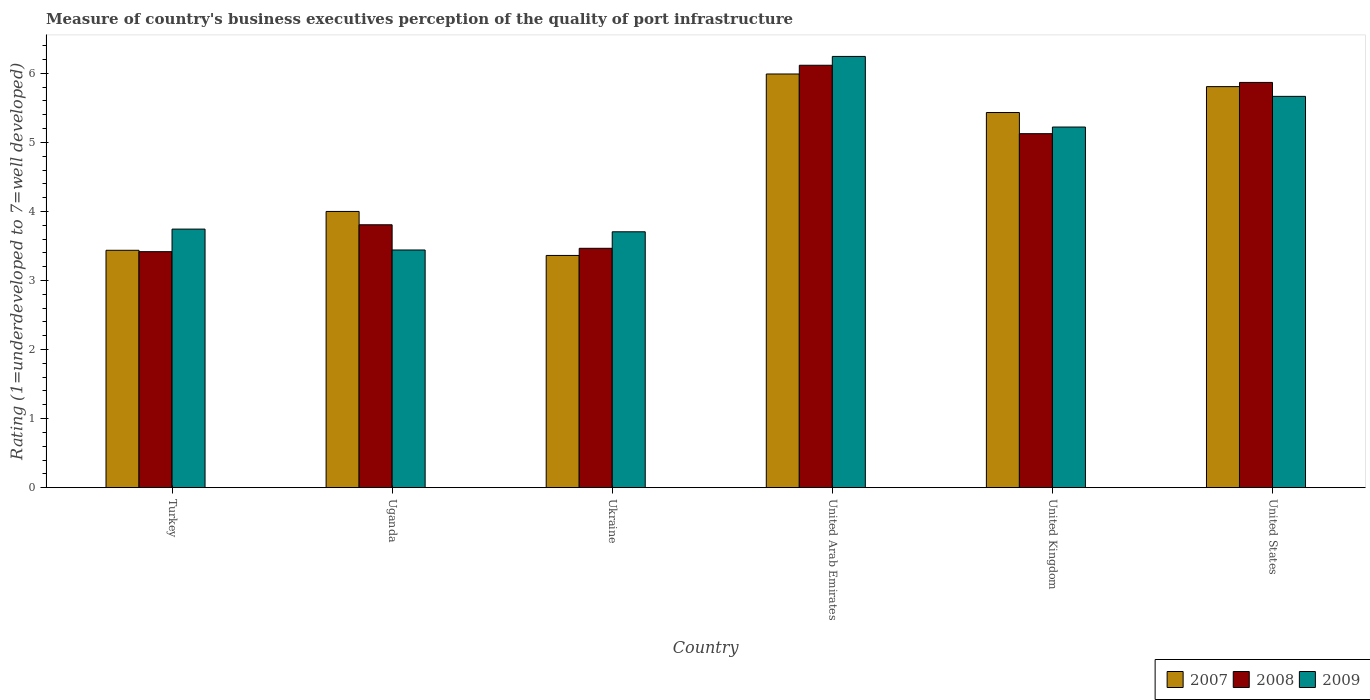How many groups of bars are there?
Offer a terse response. 6. How many bars are there on the 5th tick from the right?
Ensure brevity in your answer.  3. What is the label of the 4th group of bars from the left?
Provide a short and direct response. United Arab Emirates. In how many cases, is the number of bars for a given country not equal to the number of legend labels?
Ensure brevity in your answer.  0. What is the ratings of the quality of port infrastructure in 2009 in United Kingdom?
Your response must be concise. 5.22. Across all countries, what is the maximum ratings of the quality of port infrastructure in 2007?
Your answer should be compact. 5.99. Across all countries, what is the minimum ratings of the quality of port infrastructure in 2007?
Offer a very short reply. 3.36. In which country was the ratings of the quality of port infrastructure in 2007 maximum?
Your response must be concise. United Arab Emirates. In which country was the ratings of the quality of port infrastructure in 2009 minimum?
Your response must be concise. Uganda. What is the total ratings of the quality of port infrastructure in 2007 in the graph?
Offer a terse response. 28.03. What is the difference between the ratings of the quality of port infrastructure in 2007 in Uganda and that in United Kingdom?
Keep it short and to the point. -1.43. What is the difference between the ratings of the quality of port infrastructure in 2007 in United Arab Emirates and the ratings of the quality of port infrastructure in 2008 in United States?
Make the answer very short. 0.12. What is the average ratings of the quality of port infrastructure in 2009 per country?
Ensure brevity in your answer.  4.67. What is the difference between the ratings of the quality of port infrastructure of/in 2008 and ratings of the quality of port infrastructure of/in 2009 in Uganda?
Make the answer very short. 0.37. In how many countries, is the ratings of the quality of port infrastructure in 2009 greater than 5.8?
Offer a very short reply. 1. What is the ratio of the ratings of the quality of port infrastructure in 2009 in Turkey to that in Uganda?
Give a very brief answer. 1.09. Is the difference between the ratings of the quality of port infrastructure in 2008 in Turkey and Uganda greater than the difference between the ratings of the quality of port infrastructure in 2009 in Turkey and Uganda?
Make the answer very short. No. What is the difference between the highest and the second highest ratings of the quality of port infrastructure in 2008?
Your answer should be compact. -0.74. What is the difference between the highest and the lowest ratings of the quality of port infrastructure in 2008?
Make the answer very short. 2.7. In how many countries, is the ratings of the quality of port infrastructure in 2009 greater than the average ratings of the quality of port infrastructure in 2009 taken over all countries?
Keep it short and to the point. 3. Is the sum of the ratings of the quality of port infrastructure in 2009 in United Kingdom and United States greater than the maximum ratings of the quality of port infrastructure in 2007 across all countries?
Give a very brief answer. Yes. What does the 3rd bar from the left in United Kingdom represents?
Make the answer very short. 2009. What does the 3rd bar from the right in United Kingdom represents?
Your response must be concise. 2007. Are all the bars in the graph horizontal?
Your answer should be very brief. No. Does the graph contain grids?
Keep it short and to the point. No. How many legend labels are there?
Give a very brief answer. 3. How are the legend labels stacked?
Give a very brief answer. Horizontal. What is the title of the graph?
Provide a succinct answer. Measure of country's business executives perception of the quality of port infrastructure. Does "1994" appear as one of the legend labels in the graph?
Give a very brief answer. No. What is the label or title of the X-axis?
Make the answer very short. Country. What is the label or title of the Y-axis?
Ensure brevity in your answer.  Rating (1=underdeveloped to 7=well developed). What is the Rating (1=underdeveloped to 7=well developed) in 2007 in Turkey?
Provide a short and direct response. 3.44. What is the Rating (1=underdeveloped to 7=well developed) of 2008 in Turkey?
Provide a short and direct response. 3.42. What is the Rating (1=underdeveloped to 7=well developed) in 2009 in Turkey?
Provide a succinct answer. 3.74. What is the Rating (1=underdeveloped to 7=well developed) in 2007 in Uganda?
Keep it short and to the point. 4. What is the Rating (1=underdeveloped to 7=well developed) in 2008 in Uganda?
Offer a terse response. 3.81. What is the Rating (1=underdeveloped to 7=well developed) of 2009 in Uganda?
Give a very brief answer. 3.44. What is the Rating (1=underdeveloped to 7=well developed) in 2007 in Ukraine?
Provide a short and direct response. 3.36. What is the Rating (1=underdeveloped to 7=well developed) of 2008 in Ukraine?
Give a very brief answer. 3.47. What is the Rating (1=underdeveloped to 7=well developed) of 2009 in Ukraine?
Your response must be concise. 3.71. What is the Rating (1=underdeveloped to 7=well developed) of 2007 in United Arab Emirates?
Offer a terse response. 5.99. What is the Rating (1=underdeveloped to 7=well developed) in 2008 in United Arab Emirates?
Keep it short and to the point. 6.12. What is the Rating (1=underdeveloped to 7=well developed) in 2009 in United Arab Emirates?
Give a very brief answer. 6.24. What is the Rating (1=underdeveloped to 7=well developed) of 2007 in United Kingdom?
Ensure brevity in your answer.  5.43. What is the Rating (1=underdeveloped to 7=well developed) in 2008 in United Kingdom?
Ensure brevity in your answer.  5.13. What is the Rating (1=underdeveloped to 7=well developed) of 2009 in United Kingdom?
Keep it short and to the point. 5.22. What is the Rating (1=underdeveloped to 7=well developed) of 2007 in United States?
Keep it short and to the point. 5.81. What is the Rating (1=underdeveloped to 7=well developed) of 2008 in United States?
Provide a short and direct response. 5.87. What is the Rating (1=underdeveloped to 7=well developed) of 2009 in United States?
Your response must be concise. 5.67. Across all countries, what is the maximum Rating (1=underdeveloped to 7=well developed) of 2007?
Make the answer very short. 5.99. Across all countries, what is the maximum Rating (1=underdeveloped to 7=well developed) of 2008?
Keep it short and to the point. 6.12. Across all countries, what is the maximum Rating (1=underdeveloped to 7=well developed) in 2009?
Offer a very short reply. 6.24. Across all countries, what is the minimum Rating (1=underdeveloped to 7=well developed) in 2007?
Offer a very short reply. 3.36. Across all countries, what is the minimum Rating (1=underdeveloped to 7=well developed) in 2008?
Offer a terse response. 3.42. Across all countries, what is the minimum Rating (1=underdeveloped to 7=well developed) in 2009?
Provide a succinct answer. 3.44. What is the total Rating (1=underdeveloped to 7=well developed) of 2007 in the graph?
Provide a succinct answer. 28.03. What is the total Rating (1=underdeveloped to 7=well developed) of 2008 in the graph?
Your answer should be very brief. 27.8. What is the total Rating (1=underdeveloped to 7=well developed) in 2009 in the graph?
Give a very brief answer. 28.03. What is the difference between the Rating (1=underdeveloped to 7=well developed) in 2007 in Turkey and that in Uganda?
Your answer should be compact. -0.56. What is the difference between the Rating (1=underdeveloped to 7=well developed) of 2008 in Turkey and that in Uganda?
Provide a succinct answer. -0.39. What is the difference between the Rating (1=underdeveloped to 7=well developed) in 2009 in Turkey and that in Uganda?
Make the answer very short. 0.3. What is the difference between the Rating (1=underdeveloped to 7=well developed) of 2007 in Turkey and that in Ukraine?
Your response must be concise. 0.07. What is the difference between the Rating (1=underdeveloped to 7=well developed) in 2008 in Turkey and that in Ukraine?
Offer a terse response. -0.05. What is the difference between the Rating (1=underdeveloped to 7=well developed) in 2009 in Turkey and that in Ukraine?
Provide a succinct answer. 0.04. What is the difference between the Rating (1=underdeveloped to 7=well developed) of 2007 in Turkey and that in United Arab Emirates?
Provide a succinct answer. -2.55. What is the difference between the Rating (1=underdeveloped to 7=well developed) in 2008 in Turkey and that in United Arab Emirates?
Your response must be concise. -2.7. What is the difference between the Rating (1=underdeveloped to 7=well developed) in 2009 in Turkey and that in United Arab Emirates?
Make the answer very short. -2.5. What is the difference between the Rating (1=underdeveloped to 7=well developed) in 2007 in Turkey and that in United Kingdom?
Your response must be concise. -2. What is the difference between the Rating (1=underdeveloped to 7=well developed) of 2008 in Turkey and that in United Kingdom?
Offer a very short reply. -1.71. What is the difference between the Rating (1=underdeveloped to 7=well developed) of 2009 in Turkey and that in United Kingdom?
Your response must be concise. -1.48. What is the difference between the Rating (1=underdeveloped to 7=well developed) in 2007 in Turkey and that in United States?
Ensure brevity in your answer.  -2.37. What is the difference between the Rating (1=underdeveloped to 7=well developed) in 2008 in Turkey and that in United States?
Offer a terse response. -2.45. What is the difference between the Rating (1=underdeveloped to 7=well developed) of 2009 in Turkey and that in United States?
Ensure brevity in your answer.  -1.92. What is the difference between the Rating (1=underdeveloped to 7=well developed) of 2007 in Uganda and that in Ukraine?
Ensure brevity in your answer.  0.64. What is the difference between the Rating (1=underdeveloped to 7=well developed) of 2008 in Uganda and that in Ukraine?
Provide a succinct answer. 0.34. What is the difference between the Rating (1=underdeveloped to 7=well developed) of 2009 in Uganda and that in Ukraine?
Offer a terse response. -0.26. What is the difference between the Rating (1=underdeveloped to 7=well developed) in 2007 in Uganda and that in United Arab Emirates?
Your answer should be very brief. -1.99. What is the difference between the Rating (1=underdeveloped to 7=well developed) of 2008 in Uganda and that in United Arab Emirates?
Your response must be concise. -2.31. What is the difference between the Rating (1=underdeveloped to 7=well developed) of 2009 in Uganda and that in United Arab Emirates?
Your answer should be compact. -2.8. What is the difference between the Rating (1=underdeveloped to 7=well developed) of 2007 in Uganda and that in United Kingdom?
Your answer should be compact. -1.43. What is the difference between the Rating (1=underdeveloped to 7=well developed) of 2008 in Uganda and that in United Kingdom?
Offer a very short reply. -1.32. What is the difference between the Rating (1=underdeveloped to 7=well developed) in 2009 in Uganda and that in United Kingdom?
Offer a very short reply. -1.78. What is the difference between the Rating (1=underdeveloped to 7=well developed) in 2007 in Uganda and that in United States?
Make the answer very short. -1.81. What is the difference between the Rating (1=underdeveloped to 7=well developed) of 2008 in Uganda and that in United States?
Your answer should be very brief. -2.06. What is the difference between the Rating (1=underdeveloped to 7=well developed) in 2009 in Uganda and that in United States?
Your response must be concise. -2.22. What is the difference between the Rating (1=underdeveloped to 7=well developed) of 2007 in Ukraine and that in United Arab Emirates?
Your answer should be very brief. -2.63. What is the difference between the Rating (1=underdeveloped to 7=well developed) in 2008 in Ukraine and that in United Arab Emirates?
Provide a short and direct response. -2.65. What is the difference between the Rating (1=underdeveloped to 7=well developed) of 2009 in Ukraine and that in United Arab Emirates?
Give a very brief answer. -2.54. What is the difference between the Rating (1=underdeveloped to 7=well developed) in 2007 in Ukraine and that in United Kingdom?
Provide a succinct answer. -2.07. What is the difference between the Rating (1=underdeveloped to 7=well developed) of 2008 in Ukraine and that in United Kingdom?
Ensure brevity in your answer.  -1.66. What is the difference between the Rating (1=underdeveloped to 7=well developed) of 2009 in Ukraine and that in United Kingdom?
Your answer should be compact. -1.52. What is the difference between the Rating (1=underdeveloped to 7=well developed) in 2007 in Ukraine and that in United States?
Provide a short and direct response. -2.44. What is the difference between the Rating (1=underdeveloped to 7=well developed) of 2008 in Ukraine and that in United States?
Make the answer very short. -2.4. What is the difference between the Rating (1=underdeveloped to 7=well developed) in 2009 in Ukraine and that in United States?
Provide a short and direct response. -1.96. What is the difference between the Rating (1=underdeveloped to 7=well developed) of 2007 in United Arab Emirates and that in United Kingdom?
Keep it short and to the point. 0.56. What is the difference between the Rating (1=underdeveloped to 7=well developed) in 2008 in United Arab Emirates and that in United Kingdom?
Keep it short and to the point. 0.99. What is the difference between the Rating (1=underdeveloped to 7=well developed) in 2009 in United Arab Emirates and that in United Kingdom?
Provide a short and direct response. 1.02. What is the difference between the Rating (1=underdeveloped to 7=well developed) of 2007 in United Arab Emirates and that in United States?
Provide a succinct answer. 0.18. What is the difference between the Rating (1=underdeveloped to 7=well developed) in 2008 in United Arab Emirates and that in United States?
Ensure brevity in your answer.  0.25. What is the difference between the Rating (1=underdeveloped to 7=well developed) of 2009 in United Arab Emirates and that in United States?
Provide a short and direct response. 0.58. What is the difference between the Rating (1=underdeveloped to 7=well developed) of 2007 in United Kingdom and that in United States?
Keep it short and to the point. -0.38. What is the difference between the Rating (1=underdeveloped to 7=well developed) in 2008 in United Kingdom and that in United States?
Your response must be concise. -0.74. What is the difference between the Rating (1=underdeveloped to 7=well developed) in 2009 in United Kingdom and that in United States?
Give a very brief answer. -0.44. What is the difference between the Rating (1=underdeveloped to 7=well developed) of 2007 in Turkey and the Rating (1=underdeveloped to 7=well developed) of 2008 in Uganda?
Give a very brief answer. -0.37. What is the difference between the Rating (1=underdeveloped to 7=well developed) in 2007 in Turkey and the Rating (1=underdeveloped to 7=well developed) in 2009 in Uganda?
Provide a short and direct response. -0. What is the difference between the Rating (1=underdeveloped to 7=well developed) in 2008 in Turkey and the Rating (1=underdeveloped to 7=well developed) in 2009 in Uganda?
Your answer should be compact. -0.02. What is the difference between the Rating (1=underdeveloped to 7=well developed) in 2007 in Turkey and the Rating (1=underdeveloped to 7=well developed) in 2008 in Ukraine?
Ensure brevity in your answer.  -0.03. What is the difference between the Rating (1=underdeveloped to 7=well developed) of 2007 in Turkey and the Rating (1=underdeveloped to 7=well developed) of 2009 in Ukraine?
Your response must be concise. -0.27. What is the difference between the Rating (1=underdeveloped to 7=well developed) in 2008 in Turkey and the Rating (1=underdeveloped to 7=well developed) in 2009 in Ukraine?
Give a very brief answer. -0.29. What is the difference between the Rating (1=underdeveloped to 7=well developed) in 2007 in Turkey and the Rating (1=underdeveloped to 7=well developed) in 2008 in United Arab Emirates?
Offer a very short reply. -2.68. What is the difference between the Rating (1=underdeveloped to 7=well developed) in 2007 in Turkey and the Rating (1=underdeveloped to 7=well developed) in 2009 in United Arab Emirates?
Provide a succinct answer. -2.81. What is the difference between the Rating (1=underdeveloped to 7=well developed) of 2008 in Turkey and the Rating (1=underdeveloped to 7=well developed) of 2009 in United Arab Emirates?
Your answer should be compact. -2.83. What is the difference between the Rating (1=underdeveloped to 7=well developed) of 2007 in Turkey and the Rating (1=underdeveloped to 7=well developed) of 2008 in United Kingdom?
Ensure brevity in your answer.  -1.69. What is the difference between the Rating (1=underdeveloped to 7=well developed) of 2007 in Turkey and the Rating (1=underdeveloped to 7=well developed) of 2009 in United Kingdom?
Your response must be concise. -1.78. What is the difference between the Rating (1=underdeveloped to 7=well developed) of 2008 in Turkey and the Rating (1=underdeveloped to 7=well developed) of 2009 in United Kingdom?
Make the answer very short. -1.8. What is the difference between the Rating (1=underdeveloped to 7=well developed) in 2007 in Turkey and the Rating (1=underdeveloped to 7=well developed) in 2008 in United States?
Your answer should be very brief. -2.43. What is the difference between the Rating (1=underdeveloped to 7=well developed) of 2007 in Turkey and the Rating (1=underdeveloped to 7=well developed) of 2009 in United States?
Your answer should be compact. -2.23. What is the difference between the Rating (1=underdeveloped to 7=well developed) in 2008 in Turkey and the Rating (1=underdeveloped to 7=well developed) in 2009 in United States?
Your answer should be very brief. -2.25. What is the difference between the Rating (1=underdeveloped to 7=well developed) in 2007 in Uganda and the Rating (1=underdeveloped to 7=well developed) in 2008 in Ukraine?
Keep it short and to the point. 0.53. What is the difference between the Rating (1=underdeveloped to 7=well developed) of 2007 in Uganda and the Rating (1=underdeveloped to 7=well developed) of 2009 in Ukraine?
Provide a short and direct response. 0.29. What is the difference between the Rating (1=underdeveloped to 7=well developed) in 2008 in Uganda and the Rating (1=underdeveloped to 7=well developed) in 2009 in Ukraine?
Your response must be concise. 0.1. What is the difference between the Rating (1=underdeveloped to 7=well developed) in 2007 in Uganda and the Rating (1=underdeveloped to 7=well developed) in 2008 in United Arab Emirates?
Ensure brevity in your answer.  -2.12. What is the difference between the Rating (1=underdeveloped to 7=well developed) in 2007 in Uganda and the Rating (1=underdeveloped to 7=well developed) in 2009 in United Arab Emirates?
Offer a terse response. -2.25. What is the difference between the Rating (1=underdeveloped to 7=well developed) in 2008 in Uganda and the Rating (1=underdeveloped to 7=well developed) in 2009 in United Arab Emirates?
Make the answer very short. -2.44. What is the difference between the Rating (1=underdeveloped to 7=well developed) in 2007 in Uganda and the Rating (1=underdeveloped to 7=well developed) in 2008 in United Kingdom?
Your answer should be very brief. -1.13. What is the difference between the Rating (1=underdeveloped to 7=well developed) in 2007 in Uganda and the Rating (1=underdeveloped to 7=well developed) in 2009 in United Kingdom?
Give a very brief answer. -1.22. What is the difference between the Rating (1=underdeveloped to 7=well developed) in 2008 in Uganda and the Rating (1=underdeveloped to 7=well developed) in 2009 in United Kingdom?
Ensure brevity in your answer.  -1.42. What is the difference between the Rating (1=underdeveloped to 7=well developed) in 2007 in Uganda and the Rating (1=underdeveloped to 7=well developed) in 2008 in United States?
Ensure brevity in your answer.  -1.87. What is the difference between the Rating (1=underdeveloped to 7=well developed) in 2007 in Uganda and the Rating (1=underdeveloped to 7=well developed) in 2009 in United States?
Provide a short and direct response. -1.67. What is the difference between the Rating (1=underdeveloped to 7=well developed) in 2008 in Uganda and the Rating (1=underdeveloped to 7=well developed) in 2009 in United States?
Offer a terse response. -1.86. What is the difference between the Rating (1=underdeveloped to 7=well developed) in 2007 in Ukraine and the Rating (1=underdeveloped to 7=well developed) in 2008 in United Arab Emirates?
Make the answer very short. -2.75. What is the difference between the Rating (1=underdeveloped to 7=well developed) of 2007 in Ukraine and the Rating (1=underdeveloped to 7=well developed) of 2009 in United Arab Emirates?
Your response must be concise. -2.88. What is the difference between the Rating (1=underdeveloped to 7=well developed) in 2008 in Ukraine and the Rating (1=underdeveloped to 7=well developed) in 2009 in United Arab Emirates?
Keep it short and to the point. -2.78. What is the difference between the Rating (1=underdeveloped to 7=well developed) in 2007 in Ukraine and the Rating (1=underdeveloped to 7=well developed) in 2008 in United Kingdom?
Give a very brief answer. -1.76. What is the difference between the Rating (1=underdeveloped to 7=well developed) of 2007 in Ukraine and the Rating (1=underdeveloped to 7=well developed) of 2009 in United Kingdom?
Offer a very short reply. -1.86. What is the difference between the Rating (1=underdeveloped to 7=well developed) of 2008 in Ukraine and the Rating (1=underdeveloped to 7=well developed) of 2009 in United Kingdom?
Provide a short and direct response. -1.76. What is the difference between the Rating (1=underdeveloped to 7=well developed) of 2007 in Ukraine and the Rating (1=underdeveloped to 7=well developed) of 2008 in United States?
Give a very brief answer. -2.51. What is the difference between the Rating (1=underdeveloped to 7=well developed) in 2007 in Ukraine and the Rating (1=underdeveloped to 7=well developed) in 2009 in United States?
Offer a terse response. -2.3. What is the difference between the Rating (1=underdeveloped to 7=well developed) of 2008 in Ukraine and the Rating (1=underdeveloped to 7=well developed) of 2009 in United States?
Ensure brevity in your answer.  -2.2. What is the difference between the Rating (1=underdeveloped to 7=well developed) in 2007 in United Arab Emirates and the Rating (1=underdeveloped to 7=well developed) in 2008 in United Kingdom?
Provide a short and direct response. 0.86. What is the difference between the Rating (1=underdeveloped to 7=well developed) in 2007 in United Arab Emirates and the Rating (1=underdeveloped to 7=well developed) in 2009 in United Kingdom?
Your answer should be compact. 0.77. What is the difference between the Rating (1=underdeveloped to 7=well developed) of 2008 in United Arab Emirates and the Rating (1=underdeveloped to 7=well developed) of 2009 in United Kingdom?
Provide a short and direct response. 0.89. What is the difference between the Rating (1=underdeveloped to 7=well developed) in 2007 in United Arab Emirates and the Rating (1=underdeveloped to 7=well developed) in 2008 in United States?
Keep it short and to the point. 0.12. What is the difference between the Rating (1=underdeveloped to 7=well developed) in 2007 in United Arab Emirates and the Rating (1=underdeveloped to 7=well developed) in 2009 in United States?
Offer a terse response. 0.32. What is the difference between the Rating (1=underdeveloped to 7=well developed) in 2008 in United Arab Emirates and the Rating (1=underdeveloped to 7=well developed) in 2009 in United States?
Provide a short and direct response. 0.45. What is the difference between the Rating (1=underdeveloped to 7=well developed) of 2007 in United Kingdom and the Rating (1=underdeveloped to 7=well developed) of 2008 in United States?
Give a very brief answer. -0.44. What is the difference between the Rating (1=underdeveloped to 7=well developed) of 2007 in United Kingdom and the Rating (1=underdeveloped to 7=well developed) of 2009 in United States?
Offer a terse response. -0.23. What is the difference between the Rating (1=underdeveloped to 7=well developed) in 2008 in United Kingdom and the Rating (1=underdeveloped to 7=well developed) in 2009 in United States?
Keep it short and to the point. -0.54. What is the average Rating (1=underdeveloped to 7=well developed) in 2007 per country?
Offer a very short reply. 4.67. What is the average Rating (1=underdeveloped to 7=well developed) in 2008 per country?
Your response must be concise. 4.63. What is the average Rating (1=underdeveloped to 7=well developed) in 2009 per country?
Ensure brevity in your answer.  4.67. What is the difference between the Rating (1=underdeveloped to 7=well developed) in 2007 and Rating (1=underdeveloped to 7=well developed) in 2008 in Turkey?
Your answer should be very brief. 0.02. What is the difference between the Rating (1=underdeveloped to 7=well developed) in 2007 and Rating (1=underdeveloped to 7=well developed) in 2009 in Turkey?
Your answer should be very brief. -0.31. What is the difference between the Rating (1=underdeveloped to 7=well developed) in 2008 and Rating (1=underdeveloped to 7=well developed) in 2009 in Turkey?
Provide a short and direct response. -0.33. What is the difference between the Rating (1=underdeveloped to 7=well developed) of 2007 and Rating (1=underdeveloped to 7=well developed) of 2008 in Uganda?
Your answer should be very brief. 0.19. What is the difference between the Rating (1=underdeveloped to 7=well developed) of 2007 and Rating (1=underdeveloped to 7=well developed) of 2009 in Uganda?
Provide a succinct answer. 0.56. What is the difference between the Rating (1=underdeveloped to 7=well developed) of 2008 and Rating (1=underdeveloped to 7=well developed) of 2009 in Uganda?
Offer a very short reply. 0.37. What is the difference between the Rating (1=underdeveloped to 7=well developed) of 2007 and Rating (1=underdeveloped to 7=well developed) of 2008 in Ukraine?
Your answer should be compact. -0.1. What is the difference between the Rating (1=underdeveloped to 7=well developed) of 2007 and Rating (1=underdeveloped to 7=well developed) of 2009 in Ukraine?
Provide a short and direct response. -0.34. What is the difference between the Rating (1=underdeveloped to 7=well developed) of 2008 and Rating (1=underdeveloped to 7=well developed) of 2009 in Ukraine?
Keep it short and to the point. -0.24. What is the difference between the Rating (1=underdeveloped to 7=well developed) of 2007 and Rating (1=underdeveloped to 7=well developed) of 2008 in United Arab Emirates?
Offer a terse response. -0.13. What is the difference between the Rating (1=underdeveloped to 7=well developed) of 2007 and Rating (1=underdeveloped to 7=well developed) of 2009 in United Arab Emirates?
Offer a very short reply. -0.25. What is the difference between the Rating (1=underdeveloped to 7=well developed) in 2008 and Rating (1=underdeveloped to 7=well developed) in 2009 in United Arab Emirates?
Your answer should be compact. -0.13. What is the difference between the Rating (1=underdeveloped to 7=well developed) in 2007 and Rating (1=underdeveloped to 7=well developed) in 2008 in United Kingdom?
Your response must be concise. 0.31. What is the difference between the Rating (1=underdeveloped to 7=well developed) of 2007 and Rating (1=underdeveloped to 7=well developed) of 2009 in United Kingdom?
Your answer should be very brief. 0.21. What is the difference between the Rating (1=underdeveloped to 7=well developed) in 2008 and Rating (1=underdeveloped to 7=well developed) in 2009 in United Kingdom?
Offer a very short reply. -0.1. What is the difference between the Rating (1=underdeveloped to 7=well developed) of 2007 and Rating (1=underdeveloped to 7=well developed) of 2008 in United States?
Your answer should be very brief. -0.06. What is the difference between the Rating (1=underdeveloped to 7=well developed) in 2007 and Rating (1=underdeveloped to 7=well developed) in 2009 in United States?
Your answer should be compact. 0.14. What is the difference between the Rating (1=underdeveloped to 7=well developed) of 2008 and Rating (1=underdeveloped to 7=well developed) of 2009 in United States?
Provide a short and direct response. 0.2. What is the ratio of the Rating (1=underdeveloped to 7=well developed) in 2007 in Turkey to that in Uganda?
Your response must be concise. 0.86. What is the ratio of the Rating (1=underdeveloped to 7=well developed) in 2008 in Turkey to that in Uganda?
Offer a very short reply. 0.9. What is the ratio of the Rating (1=underdeveloped to 7=well developed) in 2009 in Turkey to that in Uganda?
Your response must be concise. 1.09. What is the ratio of the Rating (1=underdeveloped to 7=well developed) of 2007 in Turkey to that in Ukraine?
Ensure brevity in your answer.  1.02. What is the ratio of the Rating (1=underdeveloped to 7=well developed) in 2009 in Turkey to that in Ukraine?
Make the answer very short. 1.01. What is the ratio of the Rating (1=underdeveloped to 7=well developed) of 2007 in Turkey to that in United Arab Emirates?
Your answer should be compact. 0.57. What is the ratio of the Rating (1=underdeveloped to 7=well developed) of 2008 in Turkey to that in United Arab Emirates?
Make the answer very short. 0.56. What is the ratio of the Rating (1=underdeveloped to 7=well developed) of 2009 in Turkey to that in United Arab Emirates?
Provide a succinct answer. 0.6. What is the ratio of the Rating (1=underdeveloped to 7=well developed) in 2007 in Turkey to that in United Kingdom?
Your answer should be compact. 0.63. What is the ratio of the Rating (1=underdeveloped to 7=well developed) in 2009 in Turkey to that in United Kingdom?
Provide a succinct answer. 0.72. What is the ratio of the Rating (1=underdeveloped to 7=well developed) in 2007 in Turkey to that in United States?
Your response must be concise. 0.59. What is the ratio of the Rating (1=underdeveloped to 7=well developed) in 2008 in Turkey to that in United States?
Provide a short and direct response. 0.58. What is the ratio of the Rating (1=underdeveloped to 7=well developed) of 2009 in Turkey to that in United States?
Provide a short and direct response. 0.66. What is the ratio of the Rating (1=underdeveloped to 7=well developed) in 2007 in Uganda to that in Ukraine?
Your answer should be compact. 1.19. What is the ratio of the Rating (1=underdeveloped to 7=well developed) in 2008 in Uganda to that in Ukraine?
Your answer should be very brief. 1.1. What is the ratio of the Rating (1=underdeveloped to 7=well developed) in 2009 in Uganda to that in Ukraine?
Your response must be concise. 0.93. What is the ratio of the Rating (1=underdeveloped to 7=well developed) in 2007 in Uganda to that in United Arab Emirates?
Ensure brevity in your answer.  0.67. What is the ratio of the Rating (1=underdeveloped to 7=well developed) of 2008 in Uganda to that in United Arab Emirates?
Your response must be concise. 0.62. What is the ratio of the Rating (1=underdeveloped to 7=well developed) of 2009 in Uganda to that in United Arab Emirates?
Ensure brevity in your answer.  0.55. What is the ratio of the Rating (1=underdeveloped to 7=well developed) in 2007 in Uganda to that in United Kingdom?
Offer a terse response. 0.74. What is the ratio of the Rating (1=underdeveloped to 7=well developed) of 2008 in Uganda to that in United Kingdom?
Give a very brief answer. 0.74. What is the ratio of the Rating (1=underdeveloped to 7=well developed) in 2009 in Uganda to that in United Kingdom?
Offer a very short reply. 0.66. What is the ratio of the Rating (1=underdeveloped to 7=well developed) in 2007 in Uganda to that in United States?
Offer a terse response. 0.69. What is the ratio of the Rating (1=underdeveloped to 7=well developed) of 2008 in Uganda to that in United States?
Make the answer very short. 0.65. What is the ratio of the Rating (1=underdeveloped to 7=well developed) of 2009 in Uganda to that in United States?
Give a very brief answer. 0.61. What is the ratio of the Rating (1=underdeveloped to 7=well developed) of 2007 in Ukraine to that in United Arab Emirates?
Ensure brevity in your answer.  0.56. What is the ratio of the Rating (1=underdeveloped to 7=well developed) in 2008 in Ukraine to that in United Arab Emirates?
Ensure brevity in your answer.  0.57. What is the ratio of the Rating (1=underdeveloped to 7=well developed) in 2009 in Ukraine to that in United Arab Emirates?
Offer a very short reply. 0.59. What is the ratio of the Rating (1=underdeveloped to 7=well developed) of 2007 in Ukraine to that in United Kingdom?
Your answer should be compact. 0.62. What is the ratio of the Rating (1=underdeveloped to 7=well developed) in 2008 in Ukraine to that in United Kingdom?
Make the answer very short. 0.68. What is the ratio of the Rating (1=underdeveloped to 7=well developed) of 2009 in Ukraine to that in United Kingdom?
Offer a very short reply. 0.71. What is the ratio of the Rating (1=underdeveloped to 7=well developed) in 2007 in Ukraine to that in United States?
Make the answer very short. 0.58. What is the ratio of the Rating (1=underdeveloped to 7=well developed) in 2008 in Ukraine to that in United States?
Provide a short and direct response. 0.59. What is the ratio of the Rating (1=underdeveloped to 7=well developed) in 2009 in Ukraine to that in United States?
Your response must be concise. 0.65. What is the ratio of the Rating (1=underdeveloped to 7=well developed) in 2007 in United Arab Emirates to that in United Kingdom?
Make the answer very short. 1.1. What is the ratio of the Rating (1=underdeveloped to 7=well developed) of 2008 in United Arab Emirates to that in United Kingdom?
Your answer should be compact. 1.19. What is the ratio of the Rating (1=underdeveloped to 7=well developed) of 2009 in United Arab Emirates to that in United Kingdom?
Provide a succinct answer. 1.2. What is the ratio of the Rating (1=underdeveloped to 7=well developed) in 2007 in United Arab Emirates to that in United States?
Ensure brevity in your answer.  1.03. What is the ratio of the Rating (1=underdeveloped to 7=well developed) in 2008 in United Arab Emirates to that in United States?
Ensure brevity in your answer.  1.04. What is the ratio of the Rating (1=underdeveloped to 7=well developed) of 2009 in United Arab Emirates to that in United States?
Your response must be concise. 1.1. What is the ratio of the Rating (1=underdeveloped to 7=well developed) in 2007 in United Kingdom to that in United States?
Keep it short and to the point. 0.94. What is the ratio of the Rating (1=underdeveloped to 7=well developed) of 2008 in United Kingdom to that in United States?
Your answer should be very brief. 0.87. What is the ratio of the Rating (1=underdeveloped to 7=well developed) of 2009 in United Kingdom to that in United States?
Keep it short and to the point. 0.92. What is the difference between the highest and the second highest Rating (1=underdeveloped to 7=well developed) in 2007?
Provide a succinct answer. 0.18. What is the difference between the highest and the second highest Rating (1=underdeveloped to 7=well developed) in 2008?
Offer a terse response. 0.25. What is the difference between the highest and the second highest Rating (1=underdeveloped to 7=well developed) of 2009?
Keep it short and to the point. 0.58. What is the difference between the highest and the lowest Rating (1=underdeveloped to 7=well developed) in 2007?
Give a very brief answer. 2.63. What is the difference between the highest and the lowest Rating (1=underdeveloped to 7=well developed) in 2008?
Your response must be concise. 2.7. What is the difference between the highest and the lowest Rating (1=underdeveloped to 7=well developed) of 2009?
Your response must be concise. 2.8. 